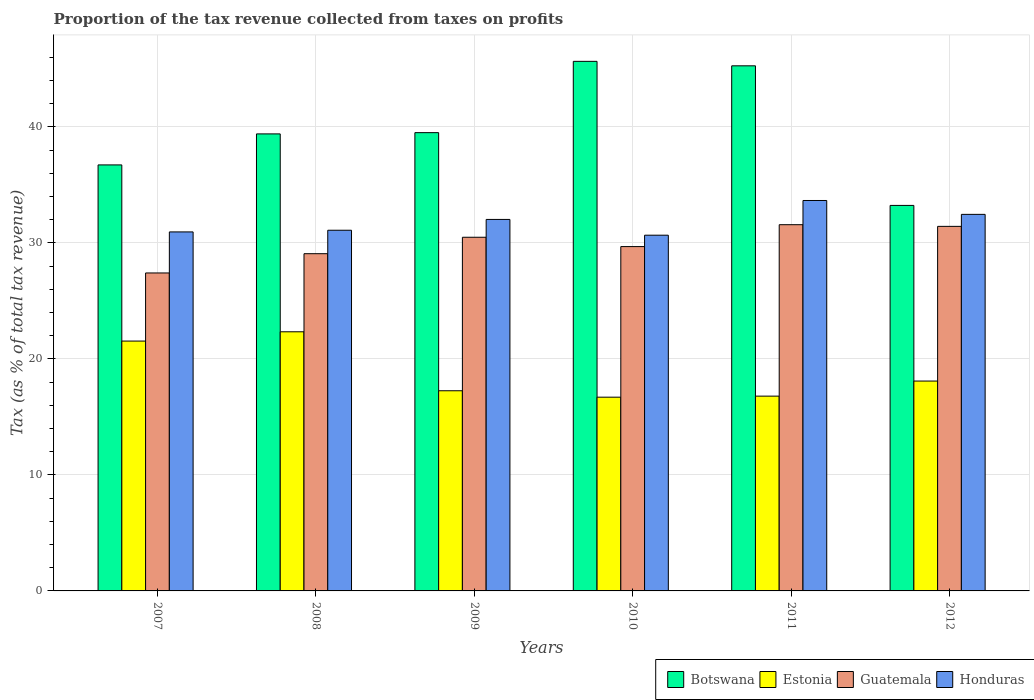How many different coloured bars are there?
Offer a very short reply. 4. How many groups of bars are there?
Offer a very short reply. 6. Are the number of bars on each tick of the X-axis equal?
Your response must be concise. Yes. How many bars are there on the 5th tick from the left?
Make the answer very short. 4. How many bars are there on the 2nd tick from the right?
Your response must be concise. 4. What is the label of the 6th group of bars from the left?
Make the answer very short. 2012. What is the proportion of the tax revenue collected in Estonia in 2011?
Your answer should be compact. 16.79. Across all years, what is the maximum proportion of the tax revenue collected in Honduras?
Give a very brief answer. 33.66. Across all years, what is the minimum proportion of the tax revenue collected in Honduras?
Give a very brief answer. 30.67. What is the total proportion of the tax revenue collected in Honduras in the graph?
Offer a very short reply. 190.88. What is the difference between the proportion of the tax revenue collected in Guatemala in 2008 and that in 2010?
Keep it short and to the point. -0.61. What is the difference between the proportion of the tax revenue collected in Guatemala in 2011 and the proportion of the tax revenue collected in Botswana in 2010?
Provide a succinct answer. -14.08. What is the average proportion of the tax revenue collected in Estonia per year?
Provide a short and direct response. 18.79. In the year 2010, what is the difference between the proportion of the tax revenue collected in Estonia and proportion of the tax revenue collected in Botswana?
Your answer should be very brief. -28.96. What is the ratio of the proportion of the tax revenue collected in Honduras in 2010 to that in 2012?
Keep it short and to the point. 0.94. What is the difference between the highest and the second highest proportion of the tax revenue collected in Guatemala?
Keep it short and to the point. 0.14. What is the difference between the highest and the lowest proportion of the tax revenue collected in Estonia?
Provide a short and direct response. 5.64. In how many years, is the proportion of the tax revenue collected in Honduras greater than the average proportion of the tax revenue collected in Honduras taken over all years?
Your response must be concise. 3. Is the sum of the proportion of the tax revenue collected in Guatemala in 2009 and 2010 greater than the maximum proportion of the tax revenue collected in Estonia across all years?
Offer a very short reply. Yes. Is it the case that in every year, the sum of the proportion of the tax revenue collected in Estonia and proportion of the tax revenue collected in Botswana is greater than the sum of proportion of the tax revenue collected in Honduras and proportion of the tax revenue collected in Guatemala?
Provide a short and direct response. No. What does the 3rd bar from the left in 2010 represents?
Your answer should be compact. Guatemala. What does the 3rd bar from the right in 2012 represents?
Your answer should be very brief. Estonia. Is it the case that in every year, the sum of the proportion of the tax revenue collected in Botswana and proportion of the tax revenue collected in Honduras is greater than the proportion of the tax revenue collected in Guatemala?
Offer a very short reply. Yes. What is the difference between two consecutive major ticks on the Y-axis?
Make the answer very short. 10. Does the graph contain any zero values?
Offer a very short reply. No. Does the graph contain grids?
Give a very brief answer. Yes. How are the legend labels stacked?
Give a very brief answer. Horizontal. What is the title of the graph?
Your response must be concise. Proportion of the tax revenue collected from taxes on profits. Does "Marshall Islands" appear as one of the legend labels in the graph?
Give a very brief answer. No. What is the label or title of the Y-axis?
Provide a succinct answer. Tax (as % of total tax revenue). What is the Tax (as % of total tax revenue) of Botswana in 2007?
Provide a short and direct response. 36.73. What is the Tax (as % of total tax revenue) in Estonia in 2007?
Make the answer very short. 21.54. What is the Tax (as % of total tax revenue) of Guatemala in 2007?
Give a very brief answer. 27.41. What is the Tax (as % of total tax revenue) of Honduras in 2007?
Provide a succinct answer. 30.95. What is the Tax (as % of total tax revenue) of Botswana in 2008?
Provide a short and direct response. 39.4. What is the Tax (as % of total tax revenue) in Estonia in 2008?
Provide a succinct answer. 22.34. What is the Tax (as % of total tax revenue) in Guatemala in 2008?
Your answer should be very brief. 29.08. What is the Tax (as % of total tax revenue) in Honduras in 2008?
Your response must be concise. 31.1. What is the Tax (as % of total tax revenue) of Botswana in 2009?
Offer a terse response. 39.51. What is the Tax (as % of total tax revenue) in Estonia in 2009?
Provide a succinct answer. 17.26. What is the Tax (as % of total tax revenue) of Guatemala in 2009?
Your answer should be compact. 30.49. What is the Tax (as % of total tax revenue) of Honduras in 2009?
Keep it short and to the point. 32.03. What is the Tax (as % of total tax revenue) in Botswana in 2010?
Keep it short and to the point. 45.66. What is the Tax (as % of total tax revenue) of Estonia in 2010?
Provide a succinct answer. 16.7. What is the Tax (as % of total tax revenue) in Guatemala in 2010?
Your response must be concise. 29.69. What is the Tax (as % of total tax revenue) in Honduras in 2010?
Your answer should be compact. 30.67. What is the Tax (as % of total tax revenue) in Botswana in 2011?
Give a very brief answer. 45.27. What is the Tax (as % of total tax revenue) in Estonia in 2011?
Keep it short and to the point. 16.79. What is the Tax (as % of total tax revenue) of Guatemala in 2011?
Offer a terse response. 31.58. What is the Tax (as % of total tax revenue) in Honduras in 2011?
Your answer should be compact. 33.66. What is the Tax (as % of total tax revenue) of Botswana in 2012?
Your answer should be compact. 33.24. What is the Tax (as % of total tax revenue) of Estonia in 2012?
Your answer should be compact. 18.09. What is the Tax (as % of total tax revenue) in Guatemala in 2012?
Provide a short and direct response. 31.43. What is the Tax (as % of total tax revenue) of Honduras in 2012?
Offer a terse response. 32.47. Across all years, what is the maximum Tax (as % of total tax revenue) of Botswana?
Ensure brevity in your answer.  45.66. Across all years, what is the maximum Tax (as % of total tax revenue) in Estonia?
Offer a very short reply. 22.34. Across all years, what is the maximum Tax (as % of total tax revenue) in Guatemala?
Provide a short and direct response. 31.58. Across all years, what is the maximum Tax (as % of total tax revenue) of Honduras?
Offer a terse response. 33.66. Across all years, what is the minimum Tax (as % of total tax revenue) of Botswana?
Your answer should be very brief. 33.24. Across all years, what is the minimum Tax (as % of total tax revenue) of Estonia?
Your answer should be very brief. 16.7. Across all years, what is the minimum Tax (as % of total tax revenue) in Guatemala?
Your response must be concise. 27.41. Across all years, what is the minimum Tax (as % of total tax revenue) in Honduras?
Provide a succinct answer. 30.67. What is the total Tax (as % of total tax revenue) of Botswana in the graph?
Your response must be concise. 239.82. What is the total Tax (as % of total tax revenue) in Estonia in the graph?
Your answer should be compact. 112.73. What is the total Tax (as % of total tax revenue) of Guatemala in the graph?
Your answer should be compact. 179.68. What is the total Tax (as % of total tax revenue) in Honduras in the graph?
Make the answer very short. 190.88. What is the difference between the Tax (as % of total tax revenue) of Botswana in 2007 and that in 2008?
Keep it short and to the point. -2.67. What is the difference between the Tax (as % of total tax revenue) of Estonia in 2007 and that in 2008?
Your answer should be very brief. -0.8. What is the difference between the Tax (as % of total tax revenue) in Guatemala in 2007 and that in 2008?
Provide a succinct answer. -1.66. What is the difference between the Tax (as % of total tax revenue) in Honduras in 2007 and that in 2008?
Provide a short and direct response. -0.15. What is the difference between the Tax (as % of total tax revenue) in Botswana in 2007 and that in 2009?
Offer a terse response. -2.78. What is the difference between the Tax (as % of total tax revenue) of Estonia in 2007 and that in 2009?
Make the answer very short. 4.28. What is the difference between the Tax (as % of total tax revenue) in Guatemala in 2007 and that in 2009?
Provide a short and direct response. -3.08. What is the difference between the Tax (as % of total tax revenue) in Honduras in 2007 and that in 2009?
Offer a very short reply. -1.08. What is the difference between the Tax (as % of total tax revenue) of Botswana in 2007 and that in 2010?
Offer a terse response. -8.93. What is the difference between the Tax (as % of total tax revenue) in Estonia in 2007 and that in 2010?
Make the answer very short. 4.84. What is the difference between the Tax (as % of total tax revenue) of Guatemala in 2007 and that in 2010?
Provide a short and direct response. -2.27. What is the difference between the Tax (as % of total tax revenue) in Honduras in 2007 and that in 2010?
Give a very brief answer. 0.28. What is the difference between the Tax (as % of total tax revenue) in Botswana in 2007 and that in 2011?
Make the answer very short. -8.54. What is the difference between the Tax (as % of total tax revenue) of Estonia in 2007 and that in 2011?
Give a very brief answer. 4.75. What is the difference between the Tax (as % of total tax revenue) of Guatemala in 2007 and that in 2011?
Keep it short and to the point. -4.16. What is the difference between the Tax (as % of total tax revenue) in Honduras in 2007 and that in 2011?
Your answer should be compact. -2.71. What is the difference between the Tax (as % of total tax revenue) of Botswana in 2007 and that in 2012?
Offer a terse response. 3.49. What is the difference between the Tax (as % of total tax revenue) of Estonia in 2007 and that in 2012?
Offer a terse response. 3.45. What is the difference between the Tax (as % of total tax revenue) in Guatemala in 2007 and that in 2012?
Your answer should be compact. -4.02. What is the difference between the Tax (as % of total tax revenue) of Honduras in 2007 and that in 2012?
Your response must be concise. -1.51. What is the difference between the Tax (as % of total tax revenue) in Botswana in 2008 and that in 2009?
Provide a short and direct response. -0.11. What is the difference between the Tax (as % of total tax revenue) of Estonia in 2008 and that in 2009?
Ensure brevity in your answer.  5.08. What is the difference between the Tax (as % of total tax revenue) in Guatemala in 2008 and that in 2009?
Ensure brevity in your answer.  -1.42. What is the difference between the Tax (as % of total tax revenue) of Honduras in 2008 and that in 2009?
Your answer should be very brief. -0.93. What is the difference between the Tax (as % of total tax revenue) of Botswana in 2008 and that in 2010?
Keep it short and to the point. -6.26. What is the difference between the Tax (as % of total tax revenue) in Estonia in 2008 and that in 2010?
Give a very brief answer. 5.64. What is the difference between the Tax (as % of total tax revenue) of Guatemala in 2008 and that in 2010?
Ensure brevity in your answer.  -0.61. What is the difference between the Tax (as % of total tax revenue) of Honduras in 2008 and that in 2010?
Keep it short and to the point. 0.43. What is the difference between the Tax (as % of total tax revenue) in Botswana in 2008 and that in 2011?
Your answer should be very brief. -5.87. What is the difference between the Tax (as % of total tax revenue) in Estonia in 2008 and that in 2011?
Offer a terse response. 5.55. What is the difference between the Tax (as % of total tax revenue) in Guatemala in 2008 and that in 2011?
Make the answer very short. -2.5. What is the difference between the Tax (as % of total tax revenue) of Honduras in 2008 and that in 2011?
Your response must be concise. -2.56. What is the difference between the Tax (as % of total tax revenue) in Botswana in 2008 and that in 2012?
Provide a succinct answer. 6.17. What is the difference between the Tax (as % of total tax revenue) of Estonia in 2008 and that in 2012?
Offer a terse response. 4.25. What is the difference between the Tax (as % of total tax revenue) in Guatemala in 2008 and that in 2012?
Make the answer very short. -2.36. What is the difference between the Tax (as % of total tax revenue) in Honduras in 2008 and that in 2012?
Give a very brief answer. -1.37. What is the difference between the Tax (as % of total tax revenue) of Botswana in 2009 and that in 2010?
Your answer should be very brief. -6.15. What is the difference between the Tax (as % of total tax revenue) of Estonia in 2009 and that in 2010?
Offer a very short reply. 0.55. What is the difference between the Tax (as % of total tax revenue) of Guatemala in 2009 and that in 2010?
Your answer should be very brief. 0.81. What is the difference between the Tax (as % of total tax revenue) of Honduras in 2009 and that in 2010?
Your answer should be very brief. 1.36. What is the difference between the Tax (as % of total tax revenue) in Botswana in 2009 and that in 2011?
Offer a terse response. -5.76. What is the difference between the Tax (as % of total tax revenue) of Estonia in 2009 and that in 2011?
Your response must be concise. 0.46. What is the difference between the Tax (as % of total tax revenue) in Guatemala in 2009 and that in 2011?
Provide a short and direct response. -1.08. What is the difference between the Tax (as % of total tax revenue) of Honduras in 2009 and that in 2011?
Offer a terse response. -1.63. What is the difference between the Tax (as % of total tax revenue) in Botswana in 2009 and that in 2012?
Give a very brief answer. 6.27. What is the difference between the Tax (as % of total tax revenue) of Estonia in 2009 and that in 2012?
Make the answer very short. -0.84. What is the difference between the Tax (as % of total tax revenue) in Guatemala in 2009 and that in 2012?
Keep it short and to the point. -0.94. What is the difference between the Tax (as % of total tax revenue) in Honduras in 2009 and that in 2012?
Provide a short and direct response. -0.44. What is the difference between the Tax (as % of total tax revenue) of Botswana in 2010 and that in 2011?
Keep it short and to the point. 0.39. What is the difference between the Tax (as % of total tax revenue) in Estonia in 2010 and that in 2011?
Your answer should be very brief. -0.09. What is the difference between the Tax (as % of total tax revenue) in Guatemala in 2010 and that in 2011?
Your answer should be very brief. -1.89. What is the difference between the Tax (as % of total tax revenue) of Honduras in 2010 and that in 2011?
Give a very brief answer. -2.99. What is the difference between the Tax (as % of total tax revenue) in Botswana in 2010 and that in 2012?
Offer a terse response. 12.42. What is the difference between the Tax (as % of total tax revenue) in Estonia in 2010 and that in 2012?
Offer a terse response. -1.39. What is the difference between the Tax (as % of total tax revenue) in Guatemala in 2010 and that in 2012?
Your response must be concise. -1.74. What is the difference between the Tax (as % of total tax revenue) of Honduras in 2010 and that in 2012?
Give a very brief answer. -1.79. What is the difference between the Tax (as % of total tax revenue) of Botswana in 2011 and that in 2012?
Keep it short and to the point. 12.04. What is the difference between the Tax (as % of total tax revenue) of Estonia in 2011 and that in 2012?
Your answer should be very brief. -1.3. What is the difference between the Tax (as % of total tax revenue) in Guatemala in 2011 and that in 2012?
Ensure brevity in your answer.  0.14. What is the difference between the Tax (as % of total tax revenue) of Honduras in 2011 and that in 2012?
Make the answer very short. 1.2. What is the difference between the Tax (as % of total tax revenue) of Botswana in 2007 and the Tax (as % of total tax revenue) of Estonia in 2008?
Make the answer very short. 14.39. What is the difference between the Tax (as % of total tax revenue) of Botswana in 2007 and the Tax (as % of total tax revenue) of Guatemala in 2008?
Make the answer very short. 7.65. What is the difference between the Tax (as % of total tax revenue) of Botswana in 2007 and the Tax (as % of total tax revenue) of Honduras in 2008?
Provide a short and direct response. 5.63. What is the difference between the Tax (as % of total tax revenue) in Estonia in 2007 and the Tax (as % of total tax revenue) in Guatemala in 2008?
Keep it short and to the point. -7.53. What is the difference between the Tax (as % of total tax revenue) of Estonia in 2007 and the Tax (as % of total tax revenue) of Honduras in 2008?
Provide a succinct answer. -9.56. What is the difference between the Tax (as % of total tax revenue) of Guatemala in 2007 and the Tax (as % of total tax revenue) of Honduras in 2008?
Offer a terse response. -3.68. What is the difference between the Tax (as % of total tax revenue) in Botswana in 2007 and the Tax (as % of total tax revenue) in Estonia in 2009?
Offer a terse response. 19.47. What is the difference between the Tax (as % of total tax revenue) of Botswana in 2007 and the Tax (as % of total tax revenue) of Guatemala in 2009?
Give a very brief answer. 6.24. What is the difference between the Tax (as % of total tax revenue) of Botswana in 2007 and the Tax (as % of total tax revenue) of Honduras in 2009?
Keep it short and to the point. 4.7. What is the difference between the Tax (as % of total tax revenue) of Estonia in 2007 and the Tax (as % of total tax revenue) of Guatemala in 2009?
Offer a very short reply. -8.95. What is the difference between the Tax (as % of total tax revenue) of Estonia in 2007 and the Tax (as % of total tax revenue) of Honduras in 2009?
Give a very brief answer. -10.49. What is the difference between the Tax (as % of total tax revenue) of Guatemala in 2007 and the Tax (as % of total tax revenue) of Honduras in 2009?
Offer a terse response. -4.62. What is the difference between the Tax (as % of total tax revenue) in Botswana in 2007 and the Tax (as % of total tax revenue) in Estonia in 2010?
Keep it short and to the point. 20.03. What is the difference between the Tax (as % of total tax revenue) of Botswana in 2007 and the Tax (as % of total tax revenue) of Guatemala in 2010?
Your response must be concise. 7.04. What is the difference between the Tax (as % of total tax revenue) in Botswana in 2007 and the Tax (as % of total tax revenue) in Honduras in 2010?
Offer a terse response. 6.06. What is the difference between the Tax (as % of total tax revenue) in Estonia in 2007 and the Tax (as % of total tax revenue) in Guatemala in 2010?
Offer a terse response. -8.15. What is the difference between the Tax (as % of total tax revenue) of Estonia in 2007 and the Tax (as % of total tax revenue) of Honduras in 2010?
Provide a succinct answer. -9.13. What is the difference between the Tax (as % of total tax revenue) of Guatemala in 2007 and the Tax (as % of total tax revenue) of Honduras in 2010?
Offer a terse response. -3.26. What is the difference between the Tax (as % of total tax revenue) of Botswana in 2007 and the Tax (as % of total tax revenue) of Estonia in 2011?
Your answer should be compact. 19.94. What is the difference between the Tax (as % of total tax revenue) in Botswana in 2007 and the Tax (as % of total tax revenue) in Guatemala in 2011?
Keep it short and to the point. 5.15. What is the difference between the Tax (as % of total tax revenue) in Botswana in 2007 and the Tax (as % of total tax revenue) in Honduras in 2011?
Offer a terse response. 3.07. What is the difference between the Tax (as % of total tax revenue) in Estonia in 2007 and the Tax (as % of total tax revenue) in Guatemala in 2011?
Provide a succinct answer. -10.03. What is the difference between the Tax (as % of total tax revenue) in Estonia in 2007 and the Tax (as % of total tax revenue) in Honduras in 2011?
Your response must be concise. -12.12. What is the difference between the Tax (as % of total tax revenue) in Guatemala in 2007 and the Tax (as % of total tax revenue) in Honduras in 2011?
Ensure brevity in your answer.  -6.25. What is the difference between the Tax (as % of total tax revenue) in Botswana in 2007 and the Tax (as % of total tax revenue) in Estonia in 2012?
Offer a very short reply. 18.64. What is the difference between the Tax (as % of total tax revenue) of Botswana in 2007 and the Tax (as % of total tax revenue) of Guatemala in 2012?
Offer a very short reply. 5.3. What is the difference between the Tax (as % of total tax revenue) in Botswana in 2007 and the Tax (as % of total tax revenue) in Honduras in 2012?
Provide a succinct answer. 4.26. What is the difference between the Tax (as % of total tax revenue) in Estonia in 2007 and the Tax (as % of total tax revenue) in Guatemala in 2012?
Keep it short and to the point. -9.89. What is the difference between the Tax (as % of total tax revenue) of Estonia in 2007 and the Tax (as % of total tax revenue) of Honduras in 2012?
Your answer should be very brief. -10.92. What is the difference between the Tax (as % of total tax revenue) of Guatemala in 2007 and the Tax (as % of total tax revenue) of Honduras in 2012?
Provide a short and direct response. -5.05. What is the difference between the Tax (as % of total tax revenue) in Botswana in 2008 and the Tax (as % of total tax revenue) in Estonia in 2009?
Give a very brief answer. 22.15. What is the difference between the Tax (as % of total tax revenue) in Botswana in 2008 and the Tax (as % of total tax revenue) in Guatemala in 2009?
Your answer should be compact. 8.91. What is the difference between the Tax (as % of total tax revenue) of Botswana in 2008 and the Tax (as % of total tax revenue) of Honduras in 2009?
Your response must be concise. 7.37. What is the difference between the Tax (as % of total tax revenue) in Estonia in 2008 and the Tax (as % of total tax revenue) in Guatemala in 2009?
Your answer should be very brief. -8.15. What is the difference between the Tax (as % of total tax revenue) of Estonia in 2008 and the Tax (as % of total tax revenue) of Honduras in 2009?
Your response must be concise. -9.69. What is the difference between the Tax (as % of total tax revenue) in Guatemala in 2008 and the Tax (as % of total tax revenue) in Honduras in 2009?
Offer a terse response. -2.95. What is the difference between the Tax (as % of total tax revenue) of Botswana in 2008 and the Tax (as % of total tax revenue) of Estonia in 2010?
Offer a terse response. 22.7. What is the difference between the Tax (as % of total tax revenue) of Botswana in 2008 and the Tax (as % of total tax revenue) of Guatemala in 2010?
Give a very brief answer. 9.72. What is the difference between the Tax (as % of total tax revenue) in Botswana in 2008 and the Tax (as % of total tax revenue) in Honduras in 2010?
Ensure brevity in your answer.  8.73. What is the difference between the Tax (as % of total tax revenue) in Estonia in 2008 and the Tax (as % of total tax revenue) in Guatemala in 2010?
Your response must be concise. -7.35. What is the difference between the Tax (as % of total tax revenue) in Estonia in 2008 and the Tax (as % of total tax revenue) in Honduras in 2010?
Your answer should be compact. -8.33. What is the difference between the Tax (as % of total tax revenue) in Guatemala in 2008 and the Tax (as % of total tax revenue) in Honduras in 2010?
Offer a terse response. -1.6. What is the difference between the Tax (as % of total tax revenue) in Botswana in 2008 and the Tax (as % of total tax revenue) in Estonia in 2011?
Ensure brevity in your answer.  22.61. What is the difference between the Tax (as % of total tax revenue) in Botswana in 2008 and the Tax (as % of total tax revenue) in Guatemala in 2011?
Provide a succinct answer. 7.83. What is the difference between the Tax (as % of total tax revenue) of Botswana in 2008 and the Tax (as % of total tax revenue) of Honduras in 2011?
Provide a short and direct response. 5.74. What is the difference between the Tax (as % of total tax revenue) in Estonia in 2008 and the Tax (as % of total tax revenue) in Guatemala in 2011?
Keep it short and to the point. -9.23. What is the difference between the Tax (as % of total tax revenue) in Estonia in 2008 and the Tax (as % of total tax revenue) in Honduras in 2011?
Your answer should be very brief. -11.32. What is the difference between the Tax (as % of total tax revenue) of Guatemala in 2008 and the Tax (as % of total tax revenue) of Honduras in 2011?
Provide a succinct answer. -4.59. What is the difference between the Tax (as % of total tax revenue) in Botswana in 2008 and the Tax (as % of total tax revenue) in Estonia in 2012?
Your answer should be very brief. 21.31. What is the difference between the Tax (as % of total tax revenue) of Botswana in 2008 and the Tax (as % of total tax revenue) of Guatemala in 2012?
Your answer should be compact. 7.97. What is the difference between the Tax (as % of total tax revenue) of Botswana in 2008 and the Tax (as % of total tax revenue) of Honduras in 2012?
Give a very brief answer. 6.94. What is the difference between the Tax (as % of total tax revenue) in Estonia in 2008 and the Tax (as % of total tax revenue) in Guatemala in 2012?
Provide a short and direct response. -9.09. What is the difference between the Tax (as % of total tax revenue) in Estonia in 2008 and the Tax (as % of total tax revenue) in Honduras in 2012?
Ensure brevity in your answer.  -10.12. What is the difference between the Tax (as % of total tax revenue) of Guatemala in 2008 and the Tax (as % of total tax revenue) of Honduras in 2012?
Offer a terse response. -3.39. What is the difference between the Tax (as % of total tax revenue) in Botswana in 2009 and the Tax (as % of total tax revenue) in Estonia in 2010?
Keep it short and to the point. 22.81. What is the difference between the Tax (as % of total tax revenue) of Botswana in 2009 and the Tax (as % of total tax revenue) of Guatemala in 2010?
Offer a terse response. 9.82. What is the difference between the Tax (as % of total tax revenue) of Botswana in 2009 and the Tax (as % of total tax revenue) of Honduras in 2010?
Ensure brevity in your answer.  8.84. What is the difference between the Tax (as % of total tax revenue) of Estonia in 2009 and the Tax (as % of total tax revenue) of Guatemala in 2010?
Your response must be concise. -12.43. What is the difference between the Tax (as % of total tax revenue) in Estonia in 2009 and the Tax (as % of total tax revenue) in Honduras in 2010?
Offer a terse response. -13.41. What is the difference between the Tax (as % of total tax revenue) of Guatemala in 2009 and the Tax (as % of total tax revenue) of Honduras in 2010?
Your response must be concise. -0.18. What is the difference between the Tax (as % of total tax revenue) of Botswana in 2009 and the Tax (as % of total tax revenue) of Estonia in 2011?
Your answer should be compact. 22.72. What is the difference between the Tax (as % of total tax revenue) in Botswana in 2009 and the Tax (as % of total tax revenue) in Guatemala in 2011?
Make the answer very short. 7.94. What is the difference between the Tax (as % of total tax revenue) of Botswana in 2009 and the Tax (as % of total tax revenue) of Honduras in 2011?
Keep it short and to the point. 5.85. What is the difference between the Tax (as % of total tax revenue) of Estonia in 2009 and the Tax (as % of total tax revenue) of Guatemala in 2011?
Your response must be concise. -14.32. What is the difference between the Tax (as % of total tax revenue) in Estonia in 2009 and the Tax (as % of total tax revenue) in Honduras in 2011?
Give a very brief answer. -16.4. What is the difference between the Tax (as % of total tax revenue) in Guatemala in 2009 and the Tax (as % of total tax revenue) in Honduras in 2011?
Offer a terse response. -3.17. What is the difference between the Tax (as % of total tax revenue) in Botswana in 2009 and the Tax (as % of total tax revenue) in Estonia in 2012?
Make the answer very short. 21.42. What is the difference between the Tax (as % of total tax revenue) of Botswana in 2009 and the Tax (as % of total tax revenue) of Guatemala in 2012?
Provide a short and direct response. 8.08. What is the difference between the Tax (as % of total tax revenue) of Botswana in 2009 and the Tax (as % of total tax revenue) of Honduras in 2012?
Your answer should be compact. 7.05. What is the difference between the Tax (as % of total tax revenue) in Estonia in 2009 and the Tax (as % of total tax revenue) in Guatemala in 2012?
Make the answer very short. -14.17. What is the difference between the Tax (as % of total tax revenue) in Estonia in 2009 and the Tax (as % of total tax revenue) in Honduras in 2012?
Your answer should be very brief. -15.21. What is the difference between the Tax (as % of total tax revenue) in Guatemala in 2009 and the Tax (as % of total tax revenue) in Honduras in 2012?
Offer a terse response. -1.97. What is the difference between the Tax (as % of total tax revenue) in Botswana in 2010 and the Tax (as % of total tax revenue) in Estonia in 2011?
Offer a terse response. 28.86. What is the difference between the Tax (as % of total tax revenue) of Botswana in 2010 and the Tax (as % of total tax revenue) of Guatemala in 2011?
Keep it short and to the point. 14.08. What is the difference between the Tax (as % of total tax revenue) of Botswana in 2010 and the Tax (as % of total tax revenue) of Honduras in 2011?
Provide a succinct answer. 12. What is the difference between the Tax (as % of total tax revenue) in Estonia in 2010 and the Tax (as % of total tax revenue) in Guatemala in 2011?
Your answer should be compact. -14.87. What is the difference between the Tax (as % of total tax revenue) of Estonia in 2010 and the Tax (as % of total tax revenue) of Honduras in 2011?
Give a very brief answer. -16.96. What is the difference between the Tax (as % of total tax revenue) of Guatemala in 2010 and the Tax (as % of total tax revenue) of Honduras in 2011?
Offer a terse response. -3.97. What is the difference between the Tax (as % of total tax revenue) in Botswana in 2010 and the Tax (as % of total tax revenue) in Estonia in 2012?
Ensure brevity in your answer.  27.56. What is the difference between the Tax (as % of total tax revenue) in Botswana in 2010 and the Tax (as % of total tax revenue) in Guatemala in 2012?
Ensure brevity in your answer.  14.23. What is the difference between the Tax (as % of total tax revenue) of Botswana in 2010 and the Tax (as % of total tax revenue) of Honduras in 2012?
Keep it short and to the point. 13.19. What is the difference between the Tax (as % of total tax revenue) of Estonia in 2010 and the Tax (as % of total tax revenue) of Guatemala in 2012?
Make the answer very short. -14.73. What is the difference between the Tax (as % of total tax revenue) of Estonia in 2010 and the Tax (as % of total tax revenue) of Honduras in 2012?
Your answer should be very brief. -15.76. What is the difference between the Tax (as % of total tax revenue) of Guatemala in 2010 and the Tax (as % of total tax revenue) of Honduras in 2012?
Give a very brief answer. -2.78. What is the difference between the Tax (as % of total tax revenue) of Botswana in 2011 and the Tax (as % of total tax revenue) of Estonia in 2012?
Ensure brevity in your answer.  27.18. What is the difference between the Tax (as % of total tax revenue) of Botswana in 2011 and the Tax (as % of total tax revenue) of Guatemala in 2012?
Offer a very short reply. 13.84. What is the difference between the Tax (as % of total tax revenue) in Botswana in 2011 and the Tax (as % of total tax revenue) in Honduras in 2012?
Offer a very short reply. 12.81. What is the difference between the Tax (as % of total tax revenue) of Estonia in 2011 and the Tax (as % of total tax revenue) of Guatemala in 2012?
Keep it short and to the point. -14.64. What is the difference between the Tax (as % of total tax revenue) of Estonia in 2011 and the Tax (as % of total tax revenue) of Honduras in 2012?
Make the answer very short. -15.67. What is the difference between the Tax (as % of total tax revenue) in Guatemala in 2011 and the Tax (as % of total tax revenue) in Honduras in 2012?
Give a very brief answer. -0.89. What is the average Tax (as % of total tax revenue) of Botswana per year?
Your response must be concise. 39.97. What is the average Tax (as % of total tax revenue) of Estonia per year?
Provide a short and direct response. 18.79. What is the average Tax (as % of total tax revenue) in Guatemala per year?
Offer a terse response. 29.95. What is the average Tax (as % of total tax revenue) in Honduras per year?
Provide a succinct answer. 31.81. In the year 2007, what is the difference between the Tax (as % of total tax revenue) in Botswana and Tax (as % of total tax revenue) in Estonia?
Offer a very short reply. 15.19. In the year 2007, what is the difference between the Tax (as % of total tax revenue) in Botswana and Tax (as % of total tax revenue) in Guatemala?
Offer a terse response. 9.32. In the year 2007, what is the difference between the Tax (as % of total tax revenue) of Botswana and Tax (as % of total tax revenue) of Honduras?
Give a very brief answer. 5.78. In the year 2007, what is the difference between the Tax (as % of total tax revenue) of Estonia and Tax (as % of total tax revenue) of Guatemala?
Provide a succinct answer. -5.87. In the year 2007, what is the difference between the Tax (as % of total tax revenue) in Estonia and Tax (as % of total tax revenue) in Honduras?
Your response must be concise. -9.41. In the year 2007, what is the difference between the Tax (as % of total tax revenue) in Guatemala and Tax (as % of total tax revenue) in Honduras?
Offer a terse response. -3.54. In the year 2008, what is the difference between the Tax (as % of total tax revenue) in Botswana and Tax (as % of total tax revenue) in Estonia?
Your answer should be very brief. 17.06. In the year 2008, what is the difference between the Tax (as % of total tax revenue) in Botswana and Tax (as % of total tax revenue) in Guatemala?
Provide a succinct answer. 10.33. In the year 2008, what is the difference between the Tax (as % of total tax revenue) of Botswana and Tax (as % of total tax revenue) of Honduras?
Your response must be concise. 8.31. In the year 2008, what is the difference between the Tax (as % of total tax revenue) in Estonia and Tax (as % of total tax revenue) in Guatemala?
Your response must be concise. -6.73. In the year 2008, what is the difference between the Tax (as % of total tax revenue) in Estonia and Tax (as % of total tax revenue) in Honduras?
Provide a succinct answer. -8.76. In the year 2008, what is the difference between the Tax (as % of total tax revenue) in Guatemala and Tax (as % of total tax revenue) in Honduras?
Your answer should be compact. -2.02. In the year 2009, what is the difference between the Tax (as % of total tax revenue) in Botswana and Tax (as % of total tax revenue) in Estonia?
Offer a terse response. 22.25. In the year 2009, what is the difference between the Tax (as % of total tax revenue) in Botswana and Tax (as % of total tax revenue) in Guatemala?
Your response must be concise. 9.02. In the year 2009, what is the difference between the Tax (as % of total tax revenue) in Botswana and Tax (as % of total tax revenue) in Honduras?
Keep it short and to the point. 7.48. In the year 2009, what is the difference between the Tax (as % of total tax revenue) in Estonia and Tax (as % of total tax revenue) in Guatemala?
Your response must be concise. -13.24. In the year 2009, what is the difference between the Tax (as % of total tax revenue) of Estonia and Tax (as % of total tax revenue) of Honduras?
Offer a very short reply. -14.77. In the year 2009, what is the difference between the Tax (as % of total tax revenue) in Guatemala and Tax (as % of total tax revenue) in Honduras?
Your answer should be very brief. -1.54. In the year 2010, what is the difference between the Tax (as % of total tax revenue) in Botswana and Tax (as % of total tax revenue) in Estonia?
Offer a very short reply. 28.96. In the year 2010, what is the difference between the Tax (as % of total tax revenue) in Botswana and Tax (as % of total tax revenue) in Guatemala?
Make the answer very short. 15.97. In the year 2010, what is the difference between the Tax (as % of total tax revenue) of Botswana and Tax (as % of total tax revenue) of Honduras?
Offer a very short reply. 14.99. In the year 2010, what is the difference between the Tax (as % of total tax revenue) of Estonia and Tax (as % of total tax revenue) of Guatemala?
Your response must be concise. -12.98. In the year 2010, what is the difference between the Tax (as % of total tax revenue) of Estonia and Tax (as % of total tax revenue) of Honduras?
Your response must be concise. -13.97. In the year 2010, what is the difference between the Tax (as % of total tax revenue) of Guatemala and Tax (as % of total tax revenue) of Honduras?
Ensure brevity in your answer.  -0.98. In the year 2011, what is the difference between the Tax (as % of total tax revenue) in Botswana and Tax (as % of total tax revenue) in Estonia?
Your answer should be very brief. 28.48. In the year 2011, what is the difference between the Tax (as % of total tax revenue) of Botswana and Tax (as % of total tax revenue) of Guatemala?
Provide a succinct answer. 13.7. In the year 2011, what is the difference between the Tax (as % of total tax revenue) of Botswana and Tax (as % of total tax revenue) of Honduras?
Your response must be concise. 11.61. In the year 2011, what is the difference between the Tax (as % of total tax revenue) in Estonia and Tax (as % of total tax revenue) in Guatemala?
Give a very brief answer. -14.78. In the year 2011, what is the difference between the Tax (as % of total tax revenue) of Estonia and Tax (as % of total tax revenue) of Honduras?
Provide a succinct answer. -16.87. In the year 2011, what is the difference between the Tax (as % of total tax revenue) of Guatemala and Tax (as % of total tax revenue) of Honduras?
Offer a terse response. -2.09. In the year 2012, what is the difference between the Tax (as % of total tax revenue) in Botswana and Tax (as % of total tax revenue) in Estonia?
Your response must be concise. 15.14. In the year 2012, what is the difference between the Tax (as % of total tax revenue) of Botswana and Tax (as % of total tax revenue) of Guatemala?
Make the answer very short. 1.81. In the year 2012, what is the difference between the Tax (as % of total tax revenue) of Botswana and Tax (as % of total tax revenue) of Honduras?
Your answer should be very brief. 0.77. In the year 2012, what is the difference between the Tax (as % of total tax revenue) in Estonia and Tax (as % of total tax revenue) in Guatemala?
Your answer should be compact. -13.34. In the year 2012, what is the difference between the Tax (as % of total tax revenue) in Estonia and Tax (as % of total tax revenue) in Honduras?
Ensure brevity in your answer.  -14.37. In the year 2012, what is the difference between the Tax (as % of total tax revenue) of Guatemala and Tax (as % of total tax revenue) of Honduras?
Your answer should be very brief. -1.03. What is the ratio of the Tax (as % of total tax revenue) in Botswana in 2007 to that in 2008?
Keep it short and to the point. 0.93. What is the ratio of the Tax (as % of total tax revenue) of Estonia in 2007 to that in 2008?
Your response must be concise. 0.96. What is the ratio of the Tax (as % of total tax revenue) in Guatemala in 2007 to that in 2008?
Your response must be concise. 0.94. What is the ratio of the Tax (as % of total tax revenue) of Botswana in 2007 to that in 2009?
Offer a terse response. 0.93. What is the ratio of the Tax (as % of total tax revenue) of Estonia in 2007 to that in 2009?
Keep it short and to the point. 1.25. What is the ratio of the Tax (as % of total tax revenue) in Guatemala in 2007 to that in 2009?
Make the answer very short. 0.9. What is the ratio of the Tax (as % of total tax revenue) of Honduras in 2007 to that in 2009?
Provide a short and direct response. 0.97. What is the ratio of the Tax (as % of total tax revenue) of Botswana in 2007 to that in 2010?
Provide a succinct answer. 0.8. What is the ratio of the Tax (as % of total tax revenue) in Estonia in 2007 to that in 2010?
Your response must be concise. 1.29. What is the ratio of the Tax (as % of total tax revenue) of Guatemala in 2007 to that in 2010?
Keep it short and to the point. 0.92. What is the ratio of the Tax (as % of total tax revenue) in Honduras in 2007 to that in 2010?
Offer a terse response. 1.01. What is the ratio of the Tax (as % of total tax revenue) of Botswana in 2007 to that in 2011?
Offer a very short reply. 0.81. What is the ratio of the Tax (as % of total tax revenue) of Estonia in 2007 to that in 2011?
Provide a short and direct response. 1.28. What is the ratio of the Tax (as % of total tax revenue) of Guatemala in 2007 to that in 2011?
Your answer should be compact. 0.87. What is the ratio of the Tax (as % of total tax revenue) of Honduras in 2007 to that in 2011?
Offer a terse response. 0.92. What is the ratio of the Tax (as % of total tax revenue) in Botswana in 2007 to that in 2012?
Offer a very short reply. 1.11. What is the ratio of the Tax (as % of total tax revenue) in Estonia in 2007 to that in 2012?
Offer a very short reply. 1.19. What is the ratio of the Tax (as % of total tax revenue) of Guatemala in 2007 to that in 2012?
Ensure brevity in your answer.  0.87. What is the ratio of the Tax (as % of total tax revenue) in Honduras in 2007 to that in 2012?
Offer a terse response. 0.95. What is the ratio of the Tax (as % of total tax revenue) in Botswana in 2008 to that in 2009?
Make the answer very short. 1. What is the ratio of the Tax (as % of total tax revenue) of Estonia in 2008 to that in 2009?
Your answer should be compact. 1.29. What is the ratio of the Tax (as % of total tax revenue) in Guatemala in 2008 to that in 2009?
Give a very brief answer. 0.95. What is the ratio of the Tax (as % of total tax revenue) of Honduras in 2008 to that in 2009?
Make the answer very short. 0.97. What is the ratio of the Tax (as % of total tax revenue) in Botswana in 2008 to that in 2010?
Provide a succinct answer. 0.86. What is the ratio of the Tax (as % of total tax revenue) in Estonia in 2008 to that in 2010?
Your response must be concise. 1.34. What is the ratio of the Tax (as % of total tax revenue) of Guatemala in 2008 to that in 2010?
Make the answer very short. 0.98. What is the ratio of the Tax (as % of total tax revenue) in Honduras in 2008 to that in 2010?
Keep it short and to the point. 1.01. What is the ratio of the Tax (as % of total tax revenue) in Botswana in 2008 to that in 2011?
Provide a succinct answer. 0.87. What is the ratio of the Tax (as % of total tax revenue) of Estonia in 2008 to that in 2011?
Ensure brevity in your answer.  1.33. What is the ratio of the Tax (as % of total tax revenue) in Guatemala in 2008 to that in 2011?
Ensure brevity in your answer.  0.92. What is the ratio of the Tax (as % of total tax revenue) of Honduras in 2008 to that in 2011?
Offer a terse response. 0.92. What is the ratio of the Tax (as % of total tax revenue) of Botswana in 2008 to that in 2012?
Offer a very short reply. 1.19. What is the ratio of the Tax (as % of total tax revenue) in Estonia in 2008 to that in 2012?
Your answer should be very brief. 1.23. What is the ratio of the Tax (as % of total tax revenue) of Guatemala in 2008 to that in 2012?
Your response must be concise. 0.93. What is the ratio of the Tax (as % of total tax revenue) of Honduras in 2008 to that in 2012?
Provide a short and direct response. 0.96. What is the ratio of the Tax (as % of total tax revenue) of Botswana in 2009 to that in 2010?
Your answer should be compact. 0.87. What is the ratio of the Tax (as % of total tax revenue) of Estonia in 2009 to that in 2010?
Ensure brevity in your answer.  1.03. What is the ratio of the Tax (as % of total tax revenue) in Guatemala in 2009 to that in 2010?
Provide a succinct answer. 1.03. What is the ratio of the Tax (as % of total tax revenue) in Honduras in 2009 to that in 2010?
Give a very brief answer. 1.04. What is the ratio of the Tax (as % of total tax revenue) of Botswana in 2009 to that in 2011?
Provide a succinct answer. 0.87. What is the ratio of the Tax (as % of total tax revenue) in Estonia in 2009 to that in 2011?
Make the answer very short. 1.03. What is the ratio of the Tax (as % of total tax revenue) in Guatemala in 2009 to that in 2011?
Your answer should be compact. 0.97. What is the ratio of the Tax (as % of total tax revenue) of Honduras in 2009 to that in 2011?
Your response must be concise. 0.95. What is the ratio of the Tax (as % of total tax revenue) of Botswana in 2009 to that in 2012?
Give a very brief answer. 1.19. What is the ratio of the Tax (as % of total tax revenue) in Estonia in 2009 to that in 2012?
Offer a very short reply. 0.95. What is the ratio of the Tax (as % of total tax revenue) in Guatemala in 2009 to that in 2012?
Offer a very short reply. 0.97. What is the ratio of the Tax (as % of total tax revenue) of Honduras in 2009 to that in 2012?
Keep it short and to the point. 0.99. What is the ratio of the Tax (as % of total tax revenue) in Botswana in 2010 to that in 2011?
Your answer should be compact. 1.01. What is the ratio of the Tax (as % of total tax revenue) in Guatemala in 2010 to that in 2011?
Your answer should be compact. 0.94. What is the ratio of the Tax (as % of total tax revenue) of Honduras in 2010 to that in 2011?
Offer a terse response. 0.91. What is the ratio of the Tax (as % of total tax revenue) of Botswana in 2010 to that in 2012?
Provide a succinct answer. 1.37. What is the ratio of the Tax (as % of total tax revenue) of Estonia in 2010 to that in 2012?
Offer a very short reply. 0.92. What is the ratio of the Tax (as % of total tax revenue) in Guatemala in 2010 to that in 2012?
Provide a short and direct response. 0.94. What is the ratio of the Tax (as % of total tax revenue) in Honduras in 2010 to that in 2012?
Keep it short and to the point. 0.94. What is the ratio of the Tax (as % of total tax revenue) in Botswana in 2011 to that in 2012?
Your answer should be compact. 1.36. What is the ratio of the Tax (as % of total tax revenue) of Estonia in 2011 to that in 2012?
Your answer should be compact. 0.93. What is the ratio of the Tax (as % of total tax revenue) in Guatemala in 2011 to that in 2012?
Your answer should be compact. 1. What is the ratio of the Tax (as % of total tax revenue) in Honduras in 2011 to that in 2012?
Your answer should be very brief. 1.04. What is the difference between the highest and the second highest Tax (as % of total tax revenue) in Botswana?
Offer a terse response. 0.39. What is the difference between the highest and the second highest Tax (as % of total tax revenue) of Estonia?
Your answer should be compact. 0.8. What is the difference between the highest and the second highest Tax (as % of total tax revenue) of Guatemala?
Give a very brief answer. 0.14. What is the difference between the highest and the second highest Tax (as % of total tax revenue) of Honduras?
Your response must be concise. 1.2. What is the difference between the highest and the lowest Tax (as % of total tax revenue) in Botswana?
Make the answer very short. 12.42. What is the difference between the highest and the lowest Tax (as % of total tax revenue) of Estonia?
Your answer should be very brief. 5.64. What is the difference between the highest and the lowest Tax (as % of total tax revenue) of Guatemala?
Ensure brevity in your answer.  4.16. What is the difference between the highest and the lowest Tax (as % of total tax revenue) in Honduras?
Offer a very short reply. 2.99. 